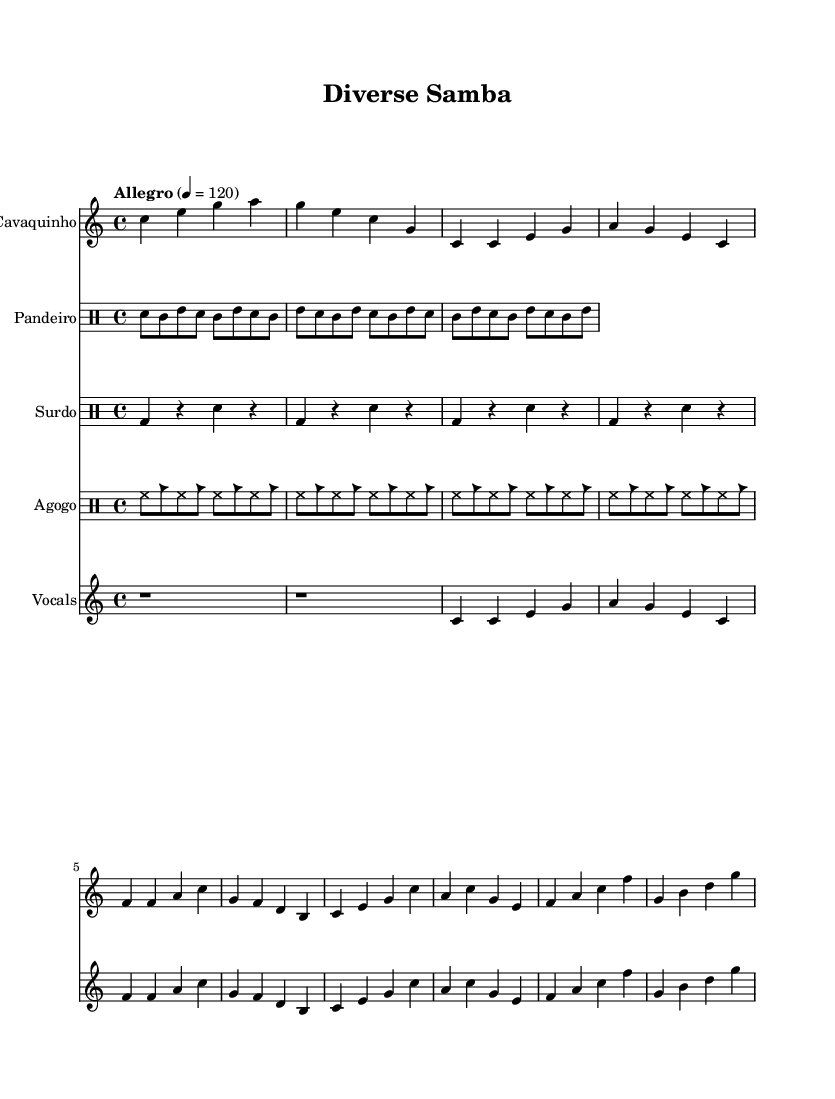What is the key signature of this music? The key signature is C major, which has no sharps or flats indicated in the music sheet.
Answer: C major What is the time signature of the piece? The time signature is shown at the beginning of the sheet music and is written as 4/4, meaning there are four beats per measure.
Answer: 4/4 What is the tempo marking for this composition? The tempo marking is specified at the beginning of the score as "Allegro," with a tempo of 120 beats per minute, indicating a fast pace.
Answer: Allegro How many measures are there in the vocal section? By counting the measures in the vocal part represented in the sheet music, we can see there are a total of 8 measures in this section.
Answer: 8 measures What instruments are included in this score? The instruments indicated at the start of each staff are Cavaquinho, Pandeiro, Surdo, Agogo, and Vocals; these represent a diverse ensemble for samba-inspired rhythms.
Answer: Cavaquinho, Pandeiro, Surdo, Agogo, Vocals What rhythmic pattern is used in the Pandeiro part? The Pandeiro rhythm pattern includes a repeating sequence of snare and tom hits, represented as "sn8 tomml tommh sn tomml tommh" and follows a 4-beat structure.
Answer: Snare and Tom pattern Which Brazilian culture is represented by the vocal melody? The vocal melody reflects samba, a significant Brazilian music genre that emphasizes rhythm and melody, celebrating diverse cultural influences.
Answer: Samba 